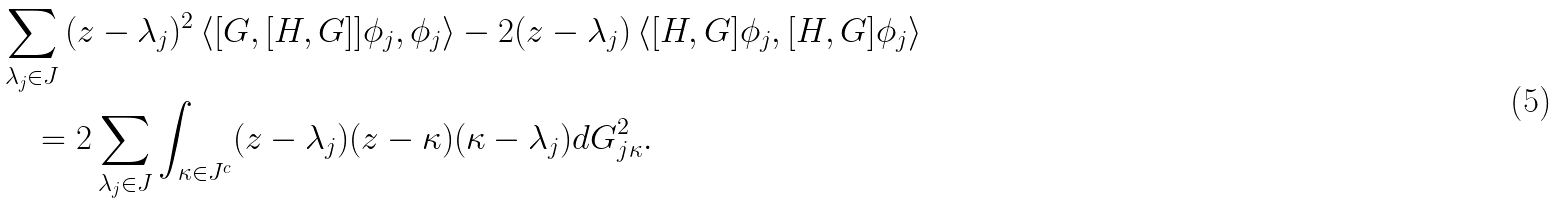<formula> <loc_0><loc_0><loc_500><loc_500>& \sum _ { \lambda _ { j } \in J } { ( z - \lambda _ { j } ) ^ { 2 } \, \langle [ G , [ H , G ] ] \phi _ { j } , \phi _ { j } \rangle - 2 ( z - \lambda _ { j } ) \, \langle [ H , G ] \phi _ { j } , [ H , G ] \phi _ { j } \rangle } \\ & \quad = 2 \sum _ { \lambda _ { j } \in J } \int _ { \kappa \in J ^ { c } } ( z - \lambda _ { j } ) ( z - \kappa ) ( \kappa - \lambda _ { j } ) d G _ { j \kappa } ^ { 2 } .</formula> 